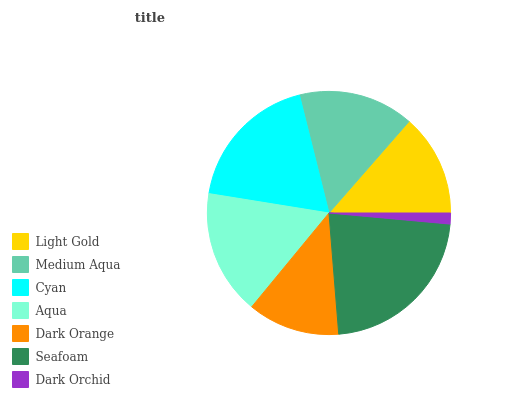Is Dark Orchid the minimum?
Answer yes or no. Yes. Is Seafoam the maximum?
Answer yes or no. Yes. Is Medium Aqua the minimum?
Answer yes or no. No. Is Medium Aqua the maximum?
Answer yes or no. No. Is Medium Aqua greater than Light Gold?
Answer yes or no. Yes. Is Light Gold less than Medium Aqua?
Answer yes or no. Yes. Is Light Gold greater than Medium Aqua?
Answer yes or no. No. Is Medium Aqua less than Light Gold?
Answer yes or no. No. Is Medium Aqua the high median?
Answer yes or no. Yes. Is Medium Aqua the low median?
Answer yes or no. Yes. Is Aqua the high median?
Answer yes or no. No. Is Seafoam the low median?
Answer yes or no. No. 